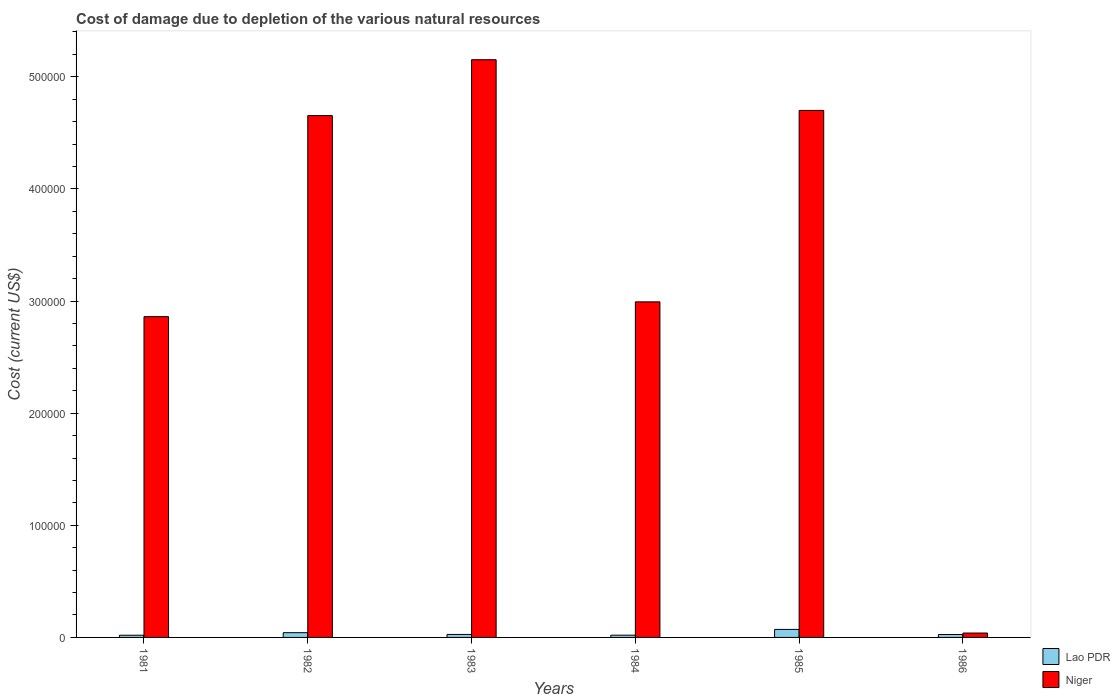How many groups of bars are there?
Offer a terse response. 6. Are the number of bars per tick equal to the number of legend labels?
Make the answer very short. Yes. Are the number of bars on each tick of the X-axis equal?
Offer a terse response. Yes. What is the cost of damage caused due to the depletion of various natural resources in Niger in 1982?
Ensure brevity in your answer.  4.65e+05. Across all years, what is the maximum cost of damage caused due to the depletion of various natural resources in Lao PDR?
Your response must be concise. 7148.62. Across all years, what is the minimum cost of damage caused due to the depletion of various natural resources in Niger?
Provide a succinct answer. 3906.97. What is the total cost of damage caused due to the depletion of various natural resources in Niger in the graph?
Make the answer very short. 2.04e+06. What is the difference between the cost of damage caused due to the depletion of various natural resources in Lao PDR in 1982 and that in 1985?
Provide a succinct answer. -2914.84. What is the difference between the cost of damage caused due to the depletion of various natural resources in Niger in 1986 and the cost of damage caused due to the depletion of various natural resources in Lao PDR in 1982?
Offer a very short reply. -326.82. What is the average cost of damage caused due to the depletion of various natural resources in Niger per year?
Offer a terse response. 3.40e+05. In the year 1981, what is the difference between the cost of damage caused due to the depletion of various natural resources in Lao PDR and cost of damage caused due to the depletion of various natural resources in Niger?
Your response must be concise. -2.84e+05. In how many years, is the cost of damage caused due to the depletion of various natural resources in Lao PDR greater than 80000 US$?
Keep it short and to the point. 0. What is the ratio of the cost of damage caused due to the depletion of various natural resources in Lao PDR in 1983 to that in 1984?
Your answer should be very brief. 1.32. Is the difference between the cost of damage caused due to the depletion of various natural resources in Lao PDR in 1982 and 1983 greater than the difference between the cost of damage caused due to the depletion of various natural resources in Niger in 1982 and 1983?
Keep it short and to the point. Yes. What is the difference between the highest and the second highest cost of damage caused due to the depletion of various natural resources in Niger?
Offer a very short reply. 4.52e+04. What is the difference between the highest and the lowest cost of damage caused due to the depletion of various natural resources in Lao PDR?
Provide a short and direct response. 5182.79. In how many years, is the cost of damage caused due to the depletion of various natural resources in Lao PDR greater than the average cost of damage caused due to the depletion of various natural resources in Lao PDR taken over all years?
Your answer should be very brief. 2. What does the 2nd bar from the left in 1981 represents?
Keep it short and to the point. Niger. What does the 1st bar from the right in 1986 represents?
Give a very brief answer. Niger. How many years are there in the graph?
Ensure brevity in your answer.  6. Where does the legend appear in the graph?
Offer a terse response. Bottom right. What is the title of the graph?
Ensure brevity in your answer.  Cost of damage due to depletion of the various natural resources. What is the label or title of the X-axis?
Your response must be concise. Years. What is the label or title of the Y-axis?
Your answer should be very brief. Cost (current US$). What is the Cost (current US$) of Lao PDR in 1981?
Your answer should be very brief. 1965.83. What is the Cost (current US$) of Niger in 1981?
Keep it short and to the point. 2.86e+05. What is the Cost (current US$) in Lao PDR in 1982?
Make the answer very short. 4233.79. What is the Cost (current US$) of Niger in 1982?
Ensure brevity in your answer.  4.65e+05. What is the Cost (current US$) in Lao PDR in 1983?
Give a very brief answer. 2659.48. What is the Cost (current US$) in Niger in 1983?
Keep it short and to the point. 5.15e+05. What is the Cost (current US$) in Lao PDR in 1984?
Your answer should be compact. 2016.19. What is the Cost (current US$) of Niger in 1984?
Keep it short and to the point. 2.99e+05. What is the Cost (current US$) of Lao PDR in 1985?
Provide a short and direct response. 7148.62. What is the Cost (current US$) of Niger in 1985?
Your answer should be very brief. 4.70e+05. What is the Cost (current US$) of Lao PDR in 1986?
Your answer should be very brief. 2605.94. What is the Cost (current US$) of Niger in 1986?
Give a very brief answer. 3906.97. Across all years, what is the maximum Cost (current US$) of Lao PDR?
Your response must be concise. 7148.62. Across all years, what is the maximum Cost (current US$) in Niger?
Keep it short and to the point. 5.15e+05. Across all years, what is the minimum Cost (current US$) of Lao PDR?
Offer a very short reply. 1965.83. Across all years, what is the minimum Cost (current US$) in Niger?
Offer a terse response. 3906.97. What is the total Cost (current US$) of Lao PDR in the graph?
Make the answer very short. 2.06e+04. What is the total Cost (current US$) in Niger in the graph?
Ensure brevity in your answer.  2.04e+06. What is the difference between the Cost (current US$) in Lao PDR in 1981 and that in 1982?
Keep it short and to the point. -2267.95. What is the difference between the Cost (current US$) in Niger in 1981 and that in 1982?
Your answer should be compact. -1.79e+05. What is the difference between the Cost (current US$) in Lao PDR in 1981 and that in 1983?
Provide a short and direct response. -693.65. What is the difference between the Cost (current US$) of Niger in 1981 and that in 1983?
Keep it short and to the point. -2.29e+05. What is the difference between the Cost (current US$) of Lao PDR in 1981 and that in 1984?
Ensure brevity in your answer.  -50.36. What is the difference between the Cost (current US$) in Niger in 1981 and that in 1984?
Provide a short and direct response. -1.32e+04. What is the difference between the Cost (current US$) in Lao PDR in 1981 and that in 1985?
Keep it short and to the point. -5182.79. What is the difference between the Cost (current US$) in Niger in 1981 and that in 1985?
Keep it short and to the point. -1.84e+05. What is the difference between the Cost (current US$) in Lao PDR in 1981 and that in 1986?
Provide a short and direct response. -640.1. What is the difference between the Cost (current US$) of Niger in 1981 and that in 1986?
Your answer should be very brief. 2.82e+05. What is the difference between the Cost (current US$) in Lao PDR in 1982 and that in 1983?
Provide a short and direct response. 1574.31. What is the difference between the Cost (current US$) in Niger in 1982 and that in 1983?
Your answer should be very brief. -4.98e+04. What is the difference between the Cost (current US$) of Lao PDR in 1982 and that in 1984?
Provide a succinct answer. 2217.6. What is the difference between the Cost (current US$) in Niger in 1982 and that in 1984?
Ensure brevity in your answer.  1.66e+05. What is the difference between the Cost (current US$) in Lao PDR in 1982 and that in 1985?
Keep it short and to the point. -2914.84. What is the difference between the Cost (current US$) in Niger in 1982 and that in 1985?
Your answer should be very brief. -4630.37. What is the difference between the Cost (current US$) of Lao PDR in 1982 and that in 1986?
Make the answer very short. 1627.85. What is the difference between the Cost (current US$) of Niger in 1982 and that in 1986?
Your answer should be compact. 4.61e+05. What is the difference between the Cost (current US$) in Lao PDR in 1983 and that in 1984?
Make the answer very short. 643.29. What is the difference between the Cost (current US$) of Niger in 1983 and that in 1984?
Ensure brevity in your answer.  2.16e+05. What is the difference between the Cost (current US$) of Lao PDR in 1983 and that in 1985?
Your response must be concise. -4489.14. What is the difference between the Cost (current US$) of Niger in 1983 and that in 1985?
Keep it short and to the point. 4.52e+04. What is the difference between the Cost (current US$) in Lao PDR in 1983 and that in 1986?
Offer a very short reply. 53.54. What is the difference between the Cost (current US$) of Niger in 1983 and that in 1986?
Provide a succinct answer. 5.11e+05. What is the difference between the Cost (current US$) of Lao PDR in 1984 and that in 1985?
Your response must be concise. -5132.43. What is the difference between the Cost (current US$) in Niger in 1984 and that in 1985?
Provide a short and direct response. -1.71e+05. What is the difference between the Cost (current US$) of Lao PDR in 1984 and that in 1986?
Offer a terse response. -589.75. What is the difference between the Cost (current US$) in Niger in 1984 and that in 1986?
Offer a very short reply. 2.95e+05. What is the difference between the Cost (current US$) of Lao PDR in 1985 and that in 1986?
Offer a terse response. 4542.69. What is the difference between the Cost (current US$) in Niger in 1985 and that in 1986?
Offer a very short reply. 4.66e+05. What is the difference between the Cost (current US$) of Lao PDR in 1981 and the Cost (current US$) of Niger in 1982?
Make the answer very short. -4.63e+05. What is the difference between the Cost (current US$) of Lao PDR in 1981 and the Cost (current US$) of Niger in 1983?
Ensure brevity in your answer.  -5.13e+05. What is the difference between the Cost (current US$) of Lao PDR in 1981 and the Cost (current US$) of Niger in 1984?
Give a very brief answer. -2.97e+05. What is the difference between the Cost (current US$) in Lao PDR in 1981 and the Cost (current US$) in Niger in 1985?
Provide a succinct answer. -4.68e+05. What is the difference between the Cost (current US$) in Lao PDR in 1981 and the Cost (current US$) in Niger in 1986?
Give a very brief answer. -1941.14. What is the difference between the Cost (current US$) of Lao PDR in 1982 and the Cost (current US$) of Niger in 1983?
Make the answer very short. -5.11e+05. What is the difference between the Cost (current US$) of Lao PDR in 1982 and the Cost (current US$) of Niger in 1984?
Make the answer very short. -2.95e+05. What is the difference between the Cost (current US$) of Lao PDR in 1982 and the Cost (current US$) of Niger in 1985?
Your answer should be very brief. -4.66e+05. What is the difference between the Cost (current US$) in Lao PDR in 1982 and the Cost (current US$) in Niger in 1986?
Keep it short and to the point. 326.82. What is the difference between the Cost (current US$) of Lao PDR in 1983 and the Cost (current US$) of Niger in 1984?
Your answer should be very brief. -2.97e+05. What is the difference between the Cost (current US$) of Lao PDR in 1983 and the Cost (current US$) of Niger in 1985?
Keep it short and to the point. -4.67e+05. What is the difference between the Cost (current US$) in Lao PDR in 1983 and the Cost (current US$) in Niger in 1986?
Your answer should be very brief. -1247.49. What is the difference between the Cost (current US$) in Lao PDR in 1984 and the Cost (current US$) in Niger in 1985?
Make the answer very short. -4.68e+05. What is the difference between the Cost (current US$) in Lao PDR in 1984 and the Cost (current US$) in Niger in 1986?
Give a very brief answer. -1890.78. What is the difference between the Cost (current US$) in Lao PDR in 1985 and the Cost (current US$) in Niger in 1986?
Your response must be concise. 3241.65. What is the average Cost (current US$) of Lao PDR per year?
Make the answer very short. 3438.31. What is the average Cost (current US$) in Niger per year?
Provide a short and direct response. 3.40e+05. In the year 1981, what is the difference between the Cost (current US$) in Lao PDR and Cost (current US$) in Niger?
Offer a terse response. -2.84e+05. In the year 1982, what is the difference between the Cost (current US$) in Lao PDR and Cost (current US$) in Niger?
Give a very brief answer. -4.61e+05. In the year 1983, what is the difference between the Cost (current US$) of Lao PDR and Cost (current US$) of Niger?
Ensure brevity in your answer.  -5.13e+05. In the year 1984, what is the difference between the Cost (current US$) in Lao PDR and Cost (current US$) in Niger?
Offer a terse response. -2.97e+05. In the year 1985, what is the difference between the Cost (current US$) in Lao PDR and Cost (current US$) in Niger?
Offer a very short reply. -4.63e+05. In the year 1986, what is the difference between the Cost (current US$) of Lao PDR and Cost (current US$) of Niger?
Provide a succinct answer. -1301.03. What is the ratio of the Cost (current US$) in Lao PDR in 1981 to that in 1982?
Your answer should be compact. 0.46. What is the ratio of the Cost (current US$) in Niger in 1981 to that in 1982?
Offer a very short reply. 0.61. What is the ratio of the Cost (current US$) of Lao PDR in 1981 to that in 1983?
Your answer should be compact. 0.74. What is the ratio of the Cost (current US$) in Niger in 1981 to that in 1983?
Provide a succinct answer. 0.56. What is the ratio of the Cost (current US$) of Lao PDR in 1981 to that in 1984?
Provide a succinct answer. 0.97. What is the ratio of the Cost (current US$) in Niger in 1981 to that in 1984?
Provide a short and direct response. 0.96. What is the ratio of the Cost (current US$) in Lao PDR in 1981 to that in 1985?
Offer a terse response. 0.28. What is the ratio of the Cost (current US$) of Niger in 1981 to that in 1985?
Provide a short and direct response. 0.61. What is the ratio of the Cost (current US$) of Lao PDR in 1981 to that in 1986?
Your answer should be compact. 0.75. What is the ratio of the Cost (current US$) of Niger in 1981 to that in 1986?
Provide a succinct answer. 73.21. What is the ratio of the Cost (current US$) of Lao PDR in 1982 to that in 1983?
Your answer should be compact. 1.59. What is the ratio of the Cost (current US$) of Niger in 1982 to that in 1983?
Your answer should be compact. 0.9. What is the ratio of the Cost (current US$) in Lao PDR in 1982 to that in 1984?
Offer a terse response. 2.1. What is the ratio of the Cost (current US$) in Niger in 1982 to that in 1984?
Keep it short and to the point. 1.56. What is the ratio of the Cost (current US$) of Lao PDR in 1982 to that in 1985?
Your response must be concise. 0.59. What is the ratio of the Cost (current US$) of Lao PDR in 1982 to that in 1986?
Your response must be concise. 1.62. What is the ratio of the Cost (current US$) of Niger in 1982 to that in 1986?
Your answer should be very brief. 119.11. What is the ratio of the Cost (current US$) of Lao PDR in 1983 to that in 1984?
Provide a short and direct response. 1.32. What is the ratio of the Cost (current US$) of Niger in 1983 to that in 1984?
Offer a terse response. 1.72. What is the ratio of the Cost (current US$) of Lao PDR in 1983 to that in 1985?
Offer a very short reply. 0.37. What is the ratio of the Cost (current US$) of Niger in 1983 to that in 1985?
Your answer should be very brief. 1.1. What is the ratio of the Cost (current US$) of Lao PDR in 1983 to that in 1986?
Offer a very short reply. 1.02. What is the ratio of the Cost (current US$) in Niger in 1983 to that in 1986?
Provide a short and direct response. 131.86. What is the ratio of the Cost (current US$) in Lao PDR in 1984 to that in 1985?
Ensure brevity in your answer.  0.28. What is the ratio of the Cost (current US$) in Niger in 1984 to that in 1985?
Give a very brief answer. 0.64. What is the ratio of the Cost (current US$) of Lao PDR in 1984 to that in 1986?
Your response must be concise. 0.77. What is the ratio of the Cost (current US$) in Niger in 1984 to that in 1986?
Make the answer very short. 76.59. What is the ratio of the Cost (current US$) in Lao PDR in 1985 to that in 1986?
Offer a very short reply. 2.74. What is the ratio of the Cost (current US$) of Niger in 1985 to that in 1986?
Your answer should be compact. 120.29. What is the difference between the highest and the second highest Cost (current US$) of Lao PDR?
Keep it short and to the point. 2914.84. What is the difference between the highest and the second highest Cost (current US$) in Niger?
Your response must be concise. 4.52e+04. What is the difference between the highest and the lowest Cost (current US$) of Lao PDR?
Give a very brief answer. 5182.79. What is the difference between the highest and the lowest Cost (current US$) in Niger?
Offer a very short reply. 5.11e+05. 